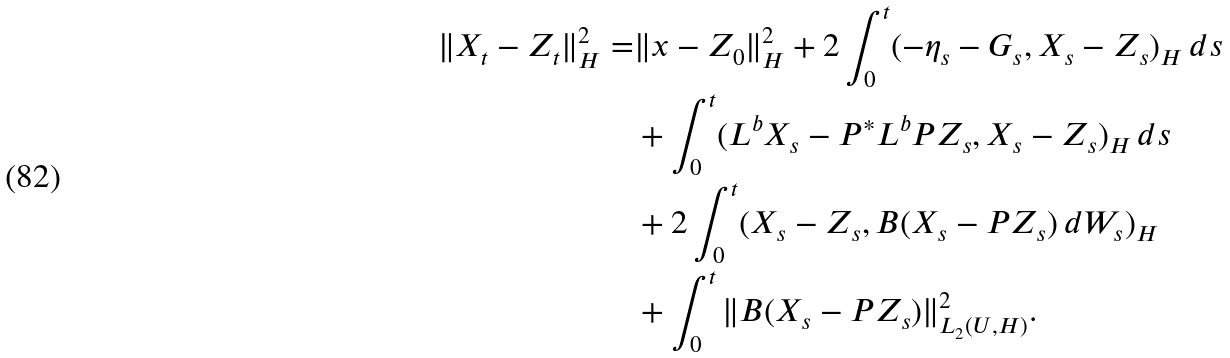Convert formula to latex. <formula><loc_0><loc_0><loc_500><loc_500>\| X _ { t } - Z _ { t } \| _ { H } ^ { 2 } = & \| x - Z _ { 0 } \| _ { H } ^ { 2 } + 2 \int _ { 0 } ^ { t } ( - \eta _ { s } - G _ { s } , X _ { s } - Z _ { s } ) _ { H } \, d s \\ & + \int _ { 0 } ^ { t } ( L ^ { b } X _ { s } - P ^ { \ast } L ^ { b } P Z _ { s } , X _ { s } - Z _ { s } ) _ { H } \, d s \\ & + 2 \int _ { 0 } ^ { t } ( X _ { s } - Z _ { s } , B ( X _ { s } - P Z _ { s } ) \, d W _ { s } ) _ { H } \\ & + \int _ { 0 } ^ { t } \| B ( X _ { s } - P Z _ { s } ) \| _ { L _ { 2 } ( U , H ) } ^ { 2 } .</formula> 